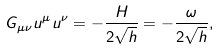<formula> <loc_0><loc_0><loc_500><loc_500>G _ { \mu \nu } u ^ { \mu } u ^ { \nu } = - \frac { H } { 2 \sqrt { h } } = - \frac { \omega } { 2 \sqrt { h } } ,</formula> 